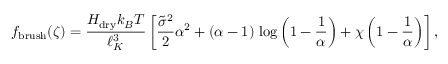Convert formula to latex. <formula><loc_0><loc_0><loc_500><loc_500>f _ { b r u s h } ( \zeta ) = \frac { H _ { d r y } k _ { B } T } { \ell _ { K } ^ { 3 } } \left [ \frac { \tilde { \sigma } ^ { 2 } } { 2 } \alpha ^ { 2 } + ( \alpha - 1 ) \, \log \left ( 1 - \frac { 1 } { \alpha } \right ) + \chi \left ( 1 - \frac { 1 } { \alpha } \right ) \right ] ,</formula> 